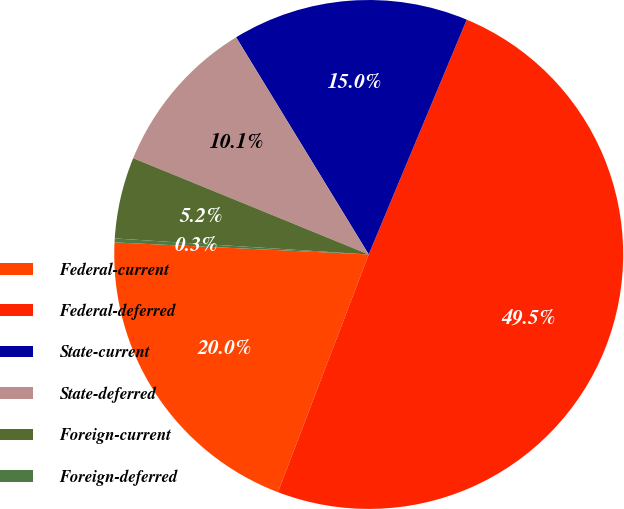Convert chart to OTSL. <chart><loc_0><loc_0><loc_500><loc_500><pie_chart><fcel>Federal-current<fcel>Federal-deferred<fcel>State-current<fcel>State-deferred<fcel>Foreign-current<fcel>Foreign-deferred<nl><fcel>19.95%<fcel>49.51%<fcel>15.02%<fcel>10.1%<fcel>5.17%<fcel>0.25%<nl></chart> 